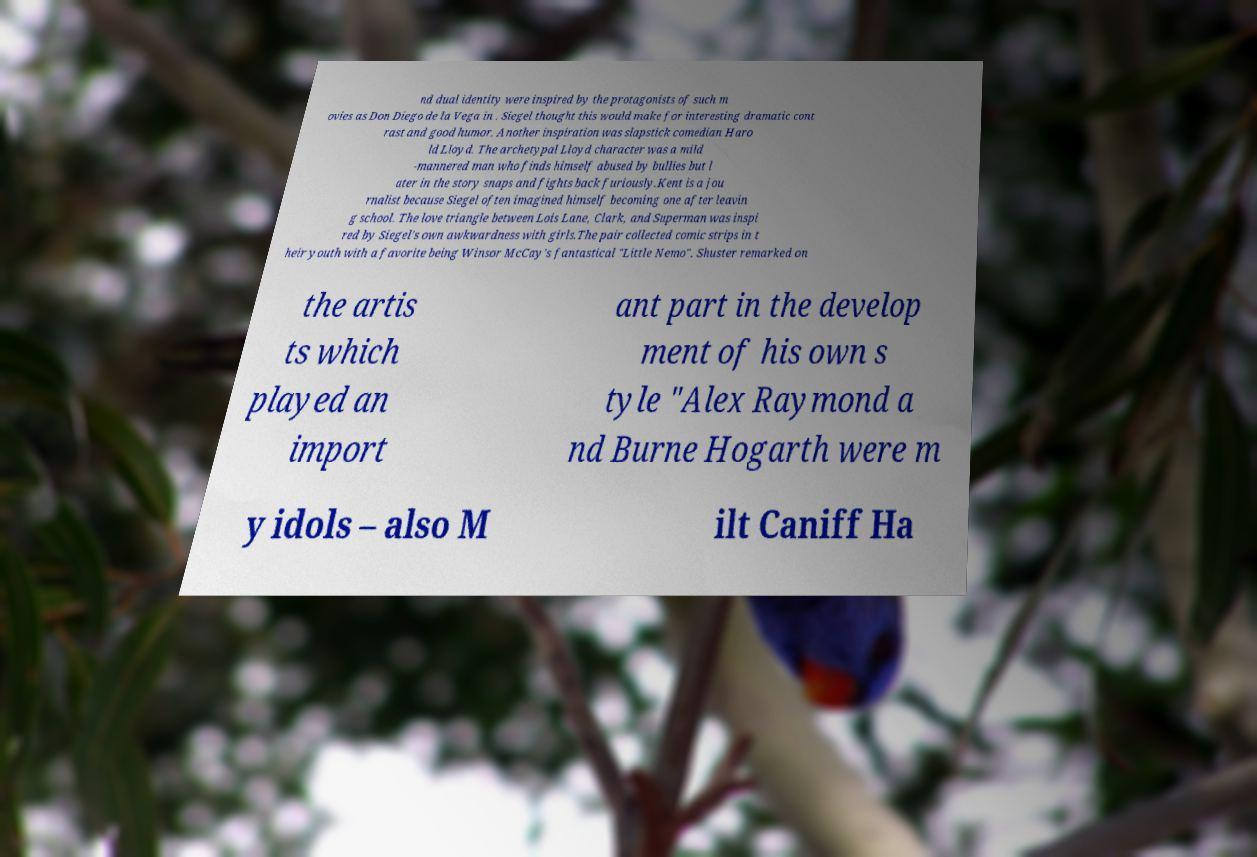Could you assist in decoding the text presented in this image and type it out clearly? nd dual identity were inspired by the protagonists of such m ovies as Don Diego de la Vega in . Siegel thought this would make for interesting dramatic cont rast and good humor. Another inspiration was slapstick comedian Haro ld Lloyd. The archetypal Lloyd character was a mild -mannered man who finds himself abused by bullies but l ater in the story snaps and fights back furiously.Kent is a jou rnalist because Siegel often imagined himself becoming one after leavin g school. The love triangle between Lois Lane, Clark, and Superman was inspi red by Siegel's own awkwardness with girls.The pair collected comic strips in t heir youth with a favorite being Winsor McCay's fantastical "Little Nemo". Shuster remarked on the artis ts which played an import ant part in the develop ment of his own s tyle "Alex Raymond a nd Burne Hogarth were m y idols – also M ilt Caniff Ha 